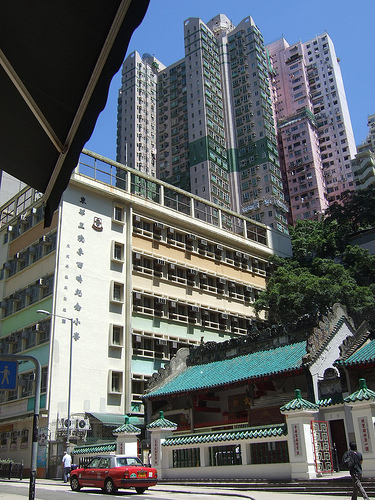<image>
Is there a building behind the car? Yes. From this viewpoint, the building is positioned behind the car, with the car partially or fully occluding the building. 